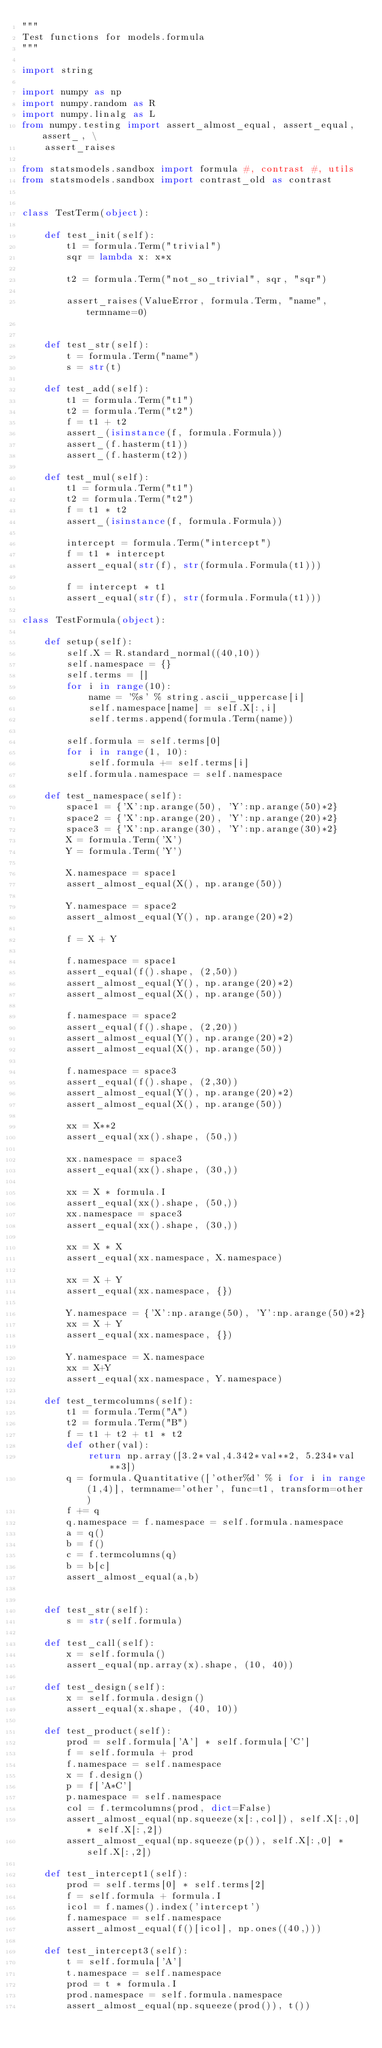Convert code to text. <code><loc_0><loc_0><loc_500><loc_500><_Python_>"""
Test functions for models.formula
"""

import string

import numpy as np
import numpy.random as R
import numpy.linalg as L
from numpy.testing import assert_almost_equal, assert_equal, assert_, \
    assert_raises

from statsmodels.sandbox import formula #, contrast #, utils
from statsmodels.sandbox import contrast_old as contrast


class TestTerm(object):

    def test_init(self):
        t1 = formula.Term("trivial")
        sqr = lambda x: x*x

        t2 = formula.Term("not_so_trivial", sqr, "sqr")

        assert_raises(ValueError, formula.Term, "name", termname=0)


    def test_str(self):
        t = formula.Term("name")
        s = str(t)

    def test_add(self):
        t1 = formula.Term("t1")
        t2 = formula.Term("t2")
        f = t1 + t2
        assert_(isinstance(f, formula.Formula))
        assert_(f.hasterm(t1))
        assert_(f.hasterm(t2))

    def test_mul(self):
        t1 = formula.Term("t1")
        t2 = formula.Term("t2")
        f = t1 * t2
        assert_(isinstance(f, formula.Formula))

        intercept = formula.Term("intercept")
        f = t1 * intercept
        assert_equal(str(f), str(formula.Formula(t1)))

        f = intercept * t1
        assert_equal(str(f), str(formula.Formula(t1)))

class TestFormula(object):

    def setup(self):
        self.X = R.standard_normal((40,10))
        self.namespace = {}
        self.terms = []
        for i in range(10):
            name = '%s' % string.ascii_uppercase[i]
            self.namespace[name] = self.X[:,i]
            self.terms.append(formula.Term(name))

        self.formula = self.terms[0]
        for i in range(1, 10):
            self.formula += self.terms[i]
        self.formula.namespace = self.namespace

    def test_namespace(self):
        space1 = {'X':np.arange(50), 'Y':np.arange(50)*2}
        space2 = {'X':np.arange(20), 'Y':np.arange(20)*2}
        space3 = {'X':np.arange(30), 'Y':np.arange(30)*2}
        X = formula.Term('X')
        Y = formula.Term('Y')

        X.namespace = space1
        assert_almost_equal(X(), np.arange(50))

        Y.namespace = space2
        assert_almost_equal(Y(), np.arange(20)*2)

        f = X + Y

        f.namespace = space1
        assert_equal(f().shape, (2,50))
        assert_almost_equal(Y(), np.arange(20)*2)
        assert_almost_equal(X(), np.arange(50))

        f.namespace = space2
        assert_equal(f().shape, (2,20))
        assert_almost_equal(Y(), np.arange(20)*2)
        assert_almost_equal(X(), np.arange(50))

        f.namespace = space3
        assert_equal(f().shape, (2,30))
        assert_almost_equal(Y(), np.arange(20)*2)
        assert_almost_equal(X(), np.arange(50))

        xx = X**2
        assert_equal(xx().shape, (50,))

        xx.namespace = space3
        assert_equal(xx().shape, (30,))

        xx = X * formula.I
        assert_equal(xx().shape, (50,))
        xx.namespace = space3
        assert_equal(xx().shape, (30,))

        xx = X * X
        assert_equal(xx.namespace, X.namespace)

        xx = X + Y
        assert_equal(xx.namespace, {})

        Y.namespace = {'X':np.arange(50), 'Y':np.arange(50)*2}
        xx = X + Y
        assert_equal(xx.namespace, {})

        Y.namespace = X.namespace
        xx = X+Y
        assert_equal(xx.namespace, Y.namespace)

    def test_termcolumns(self):
        t1 = formula.Term("A")
        t2 = formula.Term("B")
        f = t1 + t2 + t1 * t2
        def other(val):
            return np.array([3.2*val,4.342*val**2, 5.234*val**3])
        q = formula.Quantitative(['other%d' % i for i in range(1,4)], termname='other', func=t1, transform=other)
        f += q
        q.namespace = f.namespace = self.formula.namespace
        a = q()
        b = f()
        c = f.termcolumns(q)
        b = b[c]
        assert_almost_equal(a,b)


    def test_str(self):
        s = str(self.formula)

    def test_call(self):
        x = self.formula()
        assert_equal(np.array(x).shape, (10, 40))

    def test_design(self):
        x = self.formula.design()
        assert_equal(x.shape, (40, 10))

    def test_product(self):
        prod = self.formula['A'] * self.formula['C']
        f = self.formula + prod
        f.namespace = self.namespace
        x = f.design()
        p = f['A*C']
        p.namespace = self.namespace
        col = f.termcolumns(prod, dict=False)
        assert_almost_equal(np.squeeze(x[:,col]), self.X[:,0] * self.X[:,2])
        assert_almost_equal(np.squeeze(p()), self.X[:,0] * self.X[:,2])

    def test_intercept1(self):
        prod = self.terms[0] * self.terms[2]
        f = self.formula + formula.I
        icol = f.names().index('intercept')
        f.namespace = self.namespace
        assert_almost_equal(f()[icol], np.ones((40,)))

    def test_intercept3(self):
        t = self.formula['A']
        t.namespace = self.namespace
        prod = t * formula.I
        prod.namespace = self.formula.namespace
        assert_almost_equal(np.squeeze(prod()), t())
</code> 